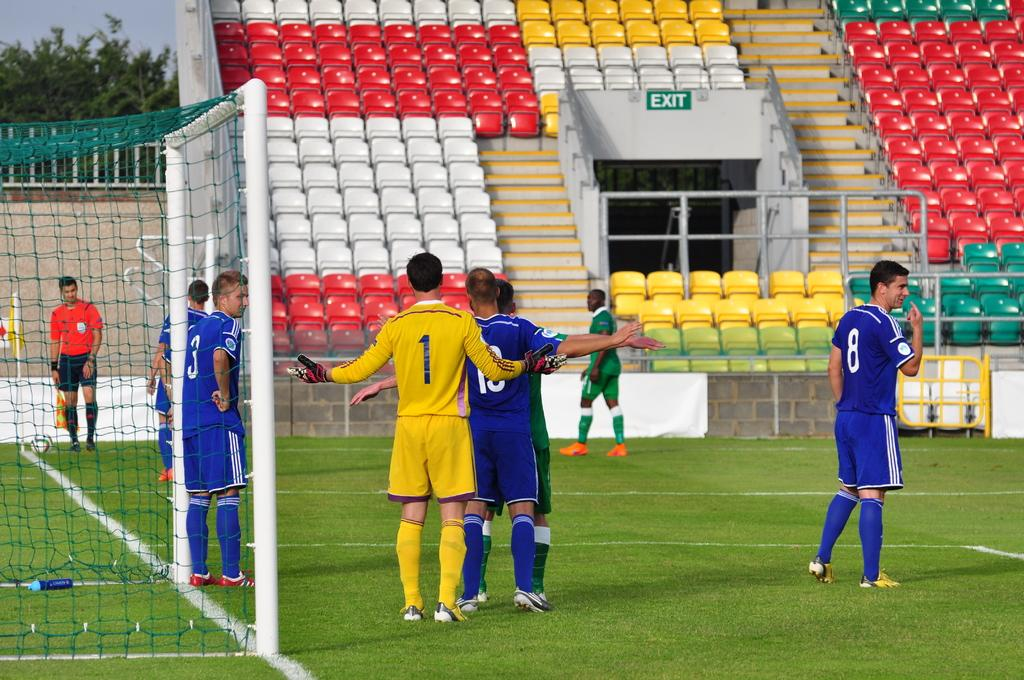<image>
Relay a brief, clear account of the picture shown. Soccer players on the field, one with the number 1 on the back of his yellow jersey. 